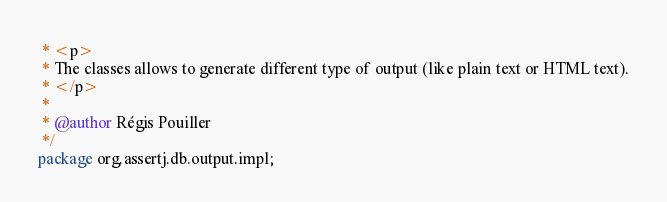<code> <loc_0><loc_0><loc_500><loc_500><_Java_> * <p>
 * The classes allows to generate different type of output (like plain text or HTML text).
 * </p>
 *
 * @author Régis Pouiller
 */
package org.assertj.db.output.impl;</code> 